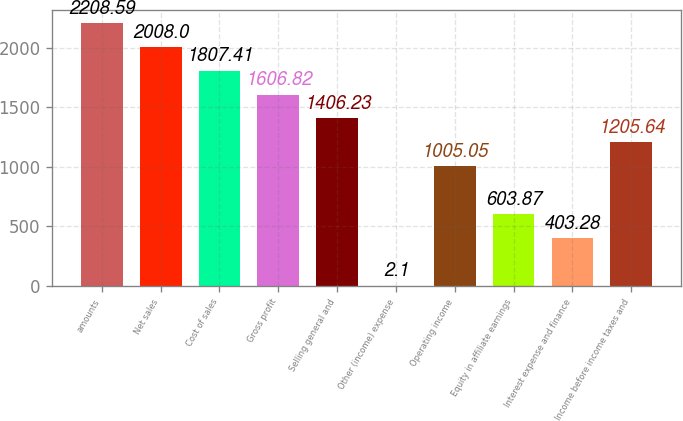Convert chart to OTSL. <chart><loc_0><loc_0><loc_500><loc_500><bar_chart><fcel>amounts<fcel>Net sales<fcel>Cost of sales<fcel>Gross profit<fcel>Selling general and<fcel>Other (income) expense<fcel>Operating income<fcel>Equity in affiliate earnings<fcel>Interest expense and finance<fcel>Income before income taxes and<nl><fcel>2208.59<fcel>2008<fcel>1807.41<fcel>1606.82<fcel>1406.23<fcel>2.1<fcel>1005.05<fcel>603.87<fcel>403.28<fcel>1205.64<nl></chart> 